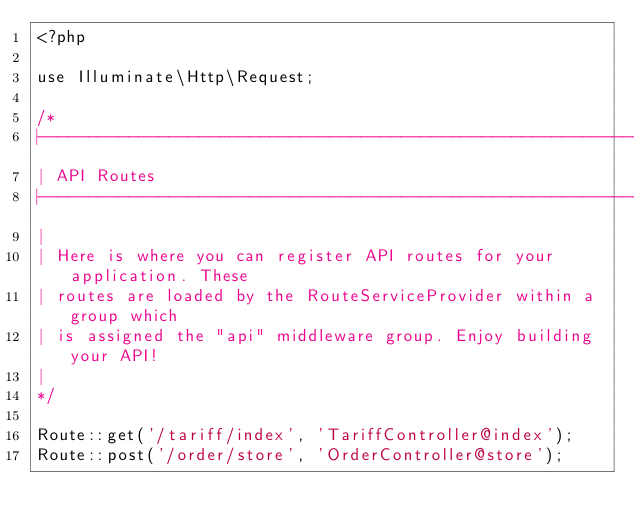Convert code to text. <code><loc_0><loc_0><loc_500><loc_500><_PHP_><?php

use Illuminate\Http\Request;

/*
|--------------------------------------------------------------------------
| API Routes
|--------------------------------------------------------------------------
|
| Here is where you can register API routes for your application. These
| routes are loaded by the RouteServiceProvider within a group which
| is assigned the "api" middleware group. Enjoy building your API!
|
*/

Route::get('/tariff/index', 'TariffController@index');
Route::post('/order/store', 'OrderController@store');
</code> 